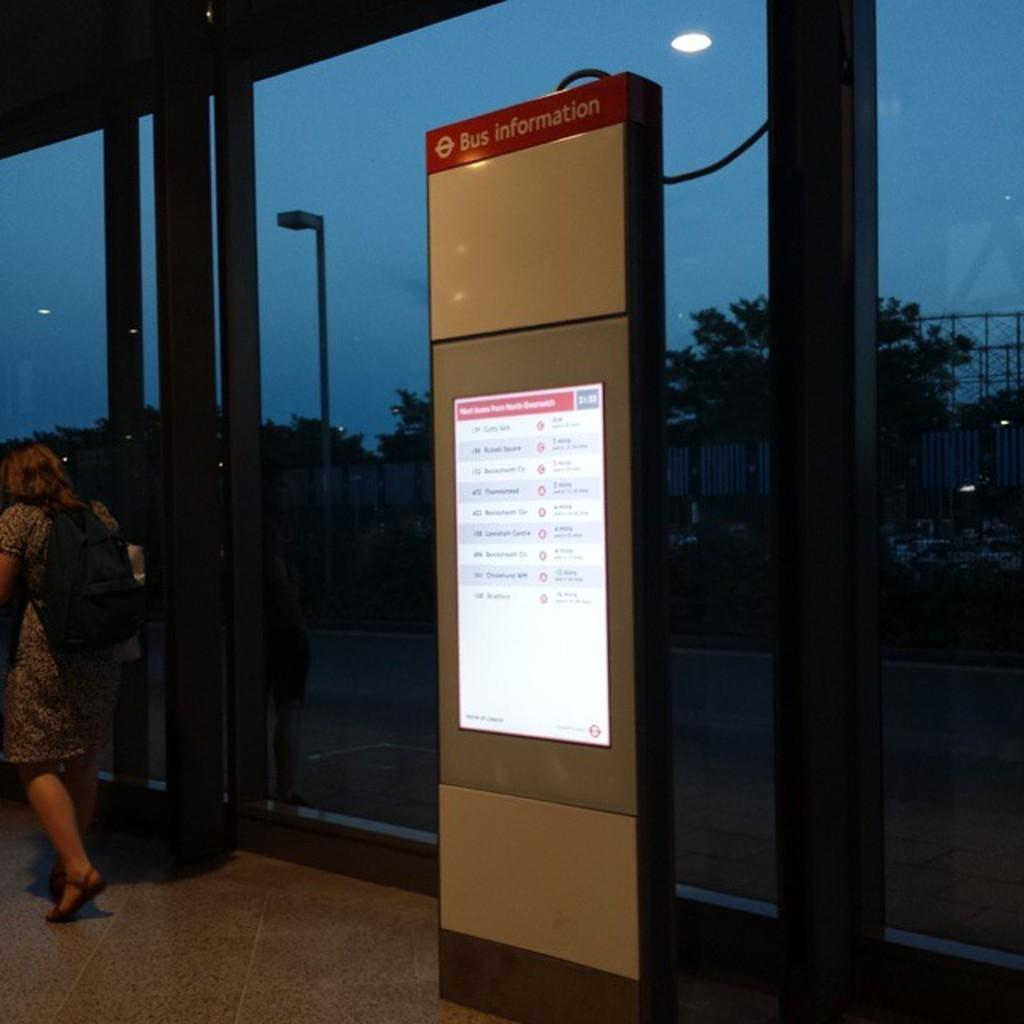What is the main object in the image? There is a screen in the image. Where is the woman located in the image? The woman is standing at the left side of the image. What is the woman holding or carrying in the image? The woman is carrying a bag. What can be seen in the distance in the image? There are trees visible in the background of the image. What is the rate at which the woman is using the hammer in the image? There is no hammer present in the image, so it is not possible to determine the rate at which the woman is using it. 